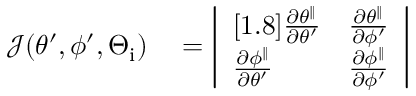<formula> <loc_0><loc_0><loc_500><loc_500>\begin{array} { r l } { \mathcal { J } ( \theta ^ { \prime } , \phi ^ { \prime } , \Theta _ { i } ) } & = \left | \begin{array} { l l } { [ 1 . 8 ] \frac { \partial \theta ^ { \| } } { \partial \theta ^ { \prime } } } & { \frac { \partial \theta ^ { \| } } { \partial \phi ^ { \prime } } } \\ { \frac { \partial \phi ^ { \| } } { \partial \theta ^ { \prime } } } & { \frac { \partial \phi ^ { \| } } { \partial \phi ^ { \prime } } } \end{array} \right | } \end{array}</formula> 